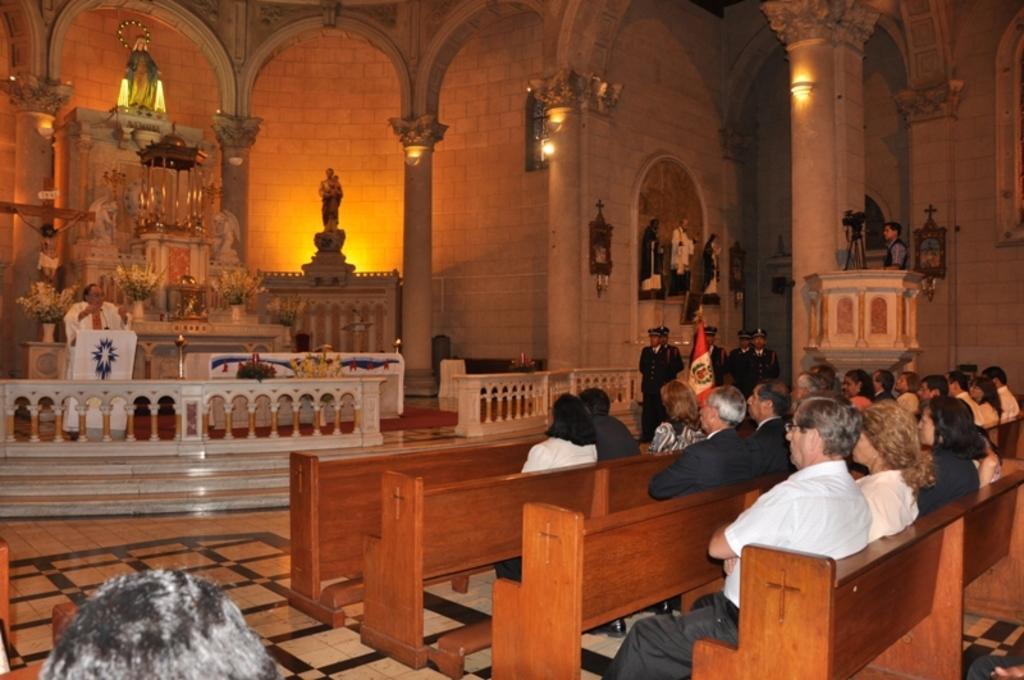Describe this image in one or two sentences. In this picture, we see people are sitting on the bench. Beside that, we see a flag in white and red color. Beside that, we see men in the uniform are standing. In the middle of the picture, we see the railing and a board in white color. We see a man is standing and in front of him, we see the podium and the microphone. He is talking on the microphone. Behind him, we see the flower vases and statues. In the background, we see a wall and the lights. This picture might be clicked in the church. 